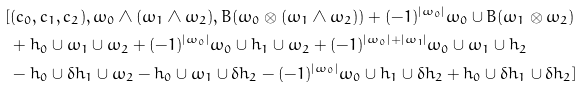Convert formula to latex. <formula><loc_0><loc_0><loc_500><loc_500>[ & ( c _ { 0 } , c _ { 1 } , c _ { 2 } ) , \omega _ { 0 } \wedge ( \omega _ { 1 } \wedge \omega _ { 2 } ) , B ( \omega _ { 0 } \otimes ( \omega _ { 1 } \wedge \omega _ { 2 } ) ) + ( - 1 ) ^ { | \omega _ { 0 } | } \omega _ { 0 } \cup B ( \omega _ { 1 } \otimes \omega _ { 2 } ) \\ & + h _ { 0 } \cup \omega _ { 1 } \cup \omega _ { 2 } + ( - 1 ) ^ { | \omega _ { 0 } | } \omega _ { 0 } \cup h _ { 1 } \cup \omega _ { 2 } + ( - 1 ) ^ { | \omega _ { 0 } | + | \omega _ { 1 } | } \omega _ { 0 } \cup \omega _ { 1 } \cup h _ { 2 } \\ & - h _ { 0 } \cup \delta h _ { 1 } \cup \omega _ { 2 } - h _ { 0 } \cup \omega _ { 1 } \cup \delta h _ { 2 } - ( - 1 ) ^ { | \omega _ { 0 } | } \omega _ { 0 } \cup h _ { 1 } \cup \delta h _ { 2 } + h _ { 0 } \cup \delta h _ { 1 } \cup \delta h _ { 2 } ]</formula> 